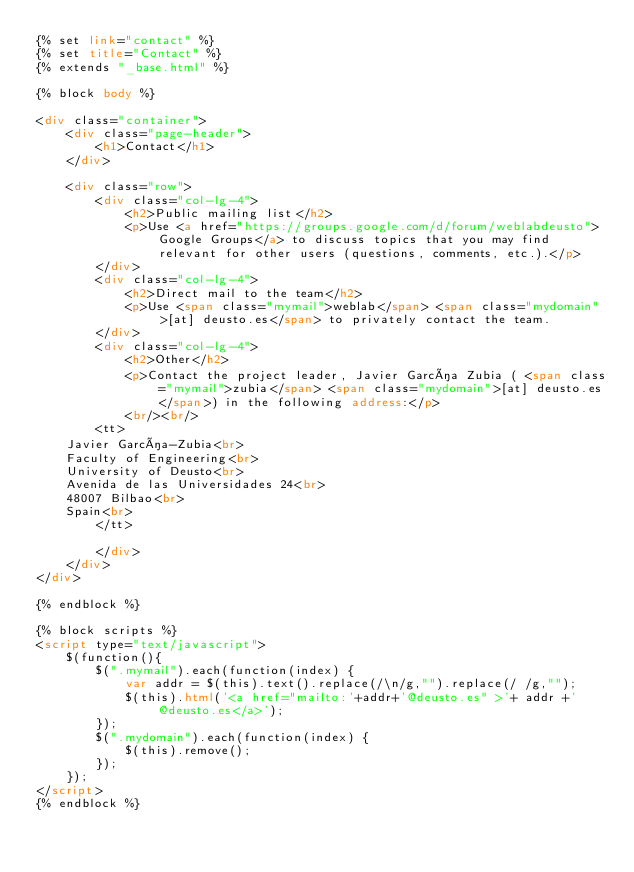Convert code to text. <code><loc_0><loc_0><loc_500><loc_500><_HTML_>{% set link="contact" %}
{% set title="Contact" %}
{% extends "_base.html" %}

{% block body %}

<div class="container">
    <div class="page-header">
        <h1>Contact</h1>
    </div>

    <div class="row">
        <div class="col-lg-4">
            <h2>Public mailing list</h2>
            <p>Use <a href="https://groups.google.com/d/forum/weblabdeusto">Google Groups</a> to discuss topics that you may find relevant for other users (questions, comments, etc.).</p>
        </div>
        <div class="col-lg-4">
            <h2>Direct mail to the team</h2>
            <p>Use <span class="mymail">weblab</span> <span class="mydomain">[at] deusto.es</span> to privately contact the team.
        </div>
        <div class="col-lg-4">
            <h2>Other</h2>
            <p>Contact the project leader, Javier García Zubia ( <span class="mymail">zubia</span> <span class="mydomain">[at] deusto.es</span>) in the following address:</p>
            <br/><br/>
        <tt>
    Javier García-Zubia<br>
    Faculty of Engineering<br>
    University of Deusto<br>
    Avenida de las Universidades 24<br>
    48007 Bilbao<br>
    Spain<br>
        </tt>

        </div>
    </div>
</div>

{% endblock %}

{% block scripts %}
<script type="text/javascript">
    $(function(){
        $(".mymail").each(function(index) {
            var addr = $(this).text().replace(/\n/g,"").replace(/ /g,"");
            $(this).html('<a href="mailto:'+addr+'@deusto.es" >'+ addr +'@deusto.es</a>');
        });
        $(".mydomain").each(function(index) {
            $(this).remove();
        });
    });
</script>
{% endblock %}
</code> 